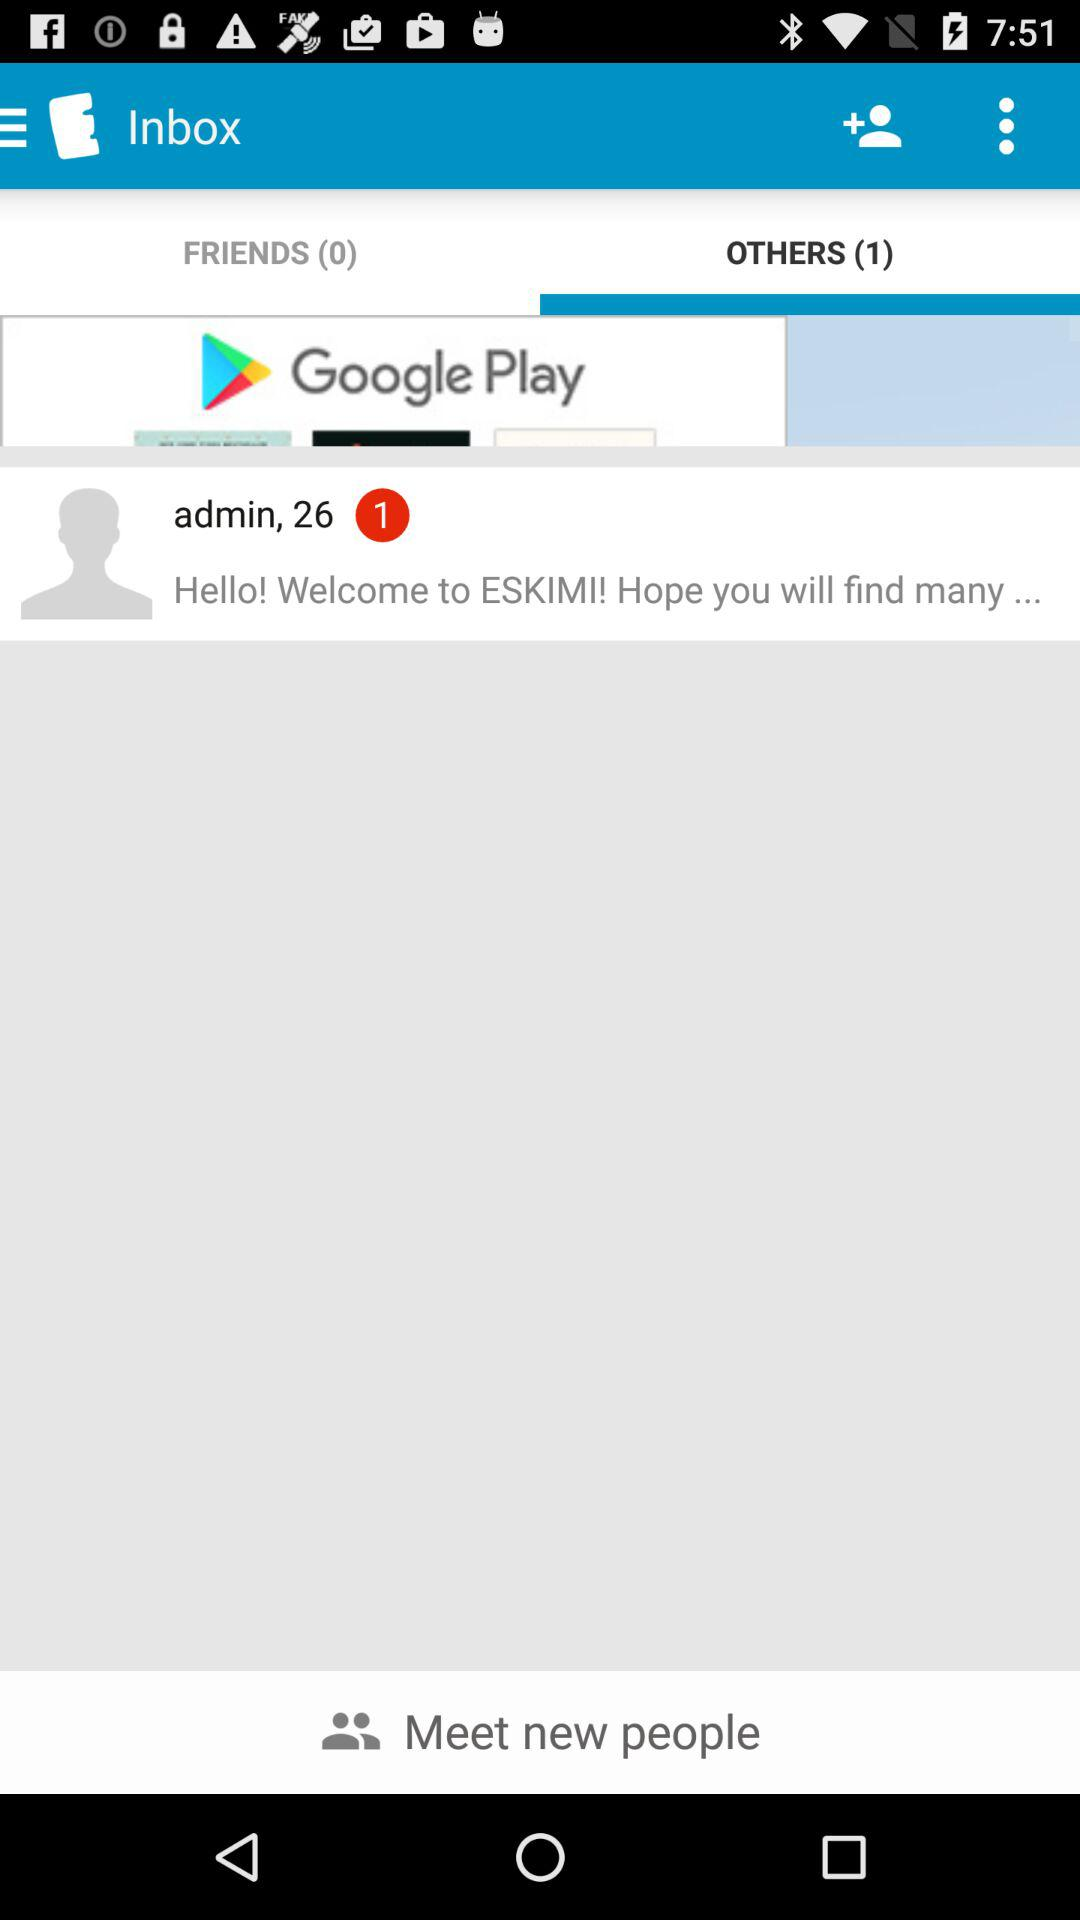How many new messages are there in the "OTHERS" option? There is 1 new message in the "OTHERS" option. 